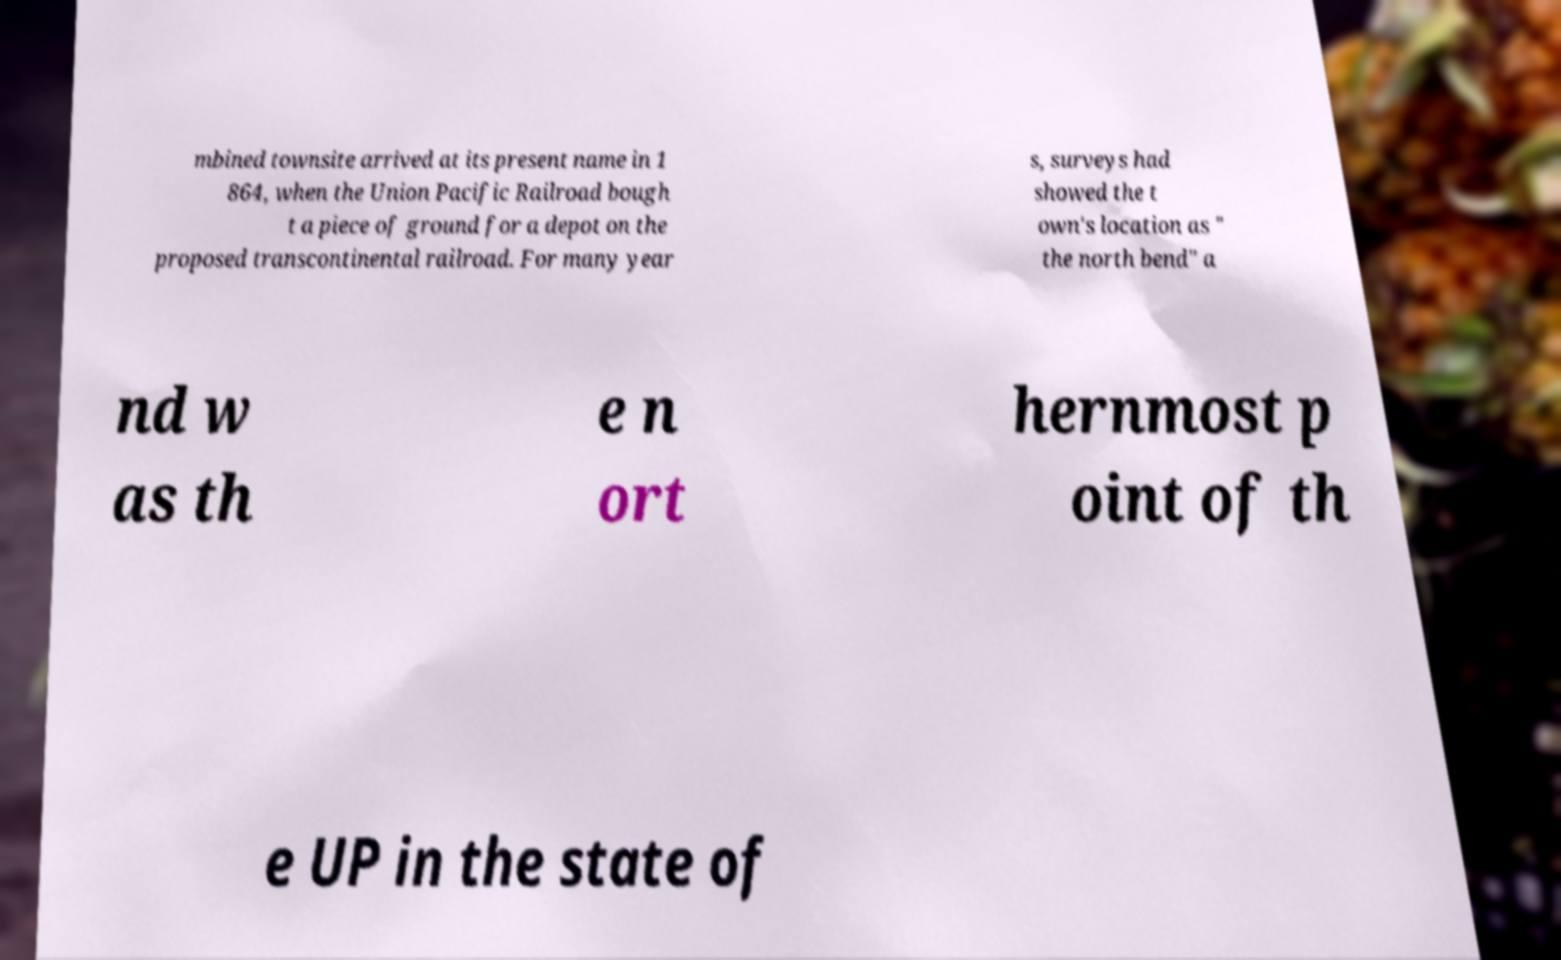Could you extract and type out the text from this image? mbined townsite arrived at its present name in 1 864, when the Union Pacific Railroad bough t a piece of ground for a depot on the proposed transcontinental railroad. For many year s, surveys had showed the t own's location as " the north bend" a nd w as th e n ort hernmost p oint of th e UP in the state of 